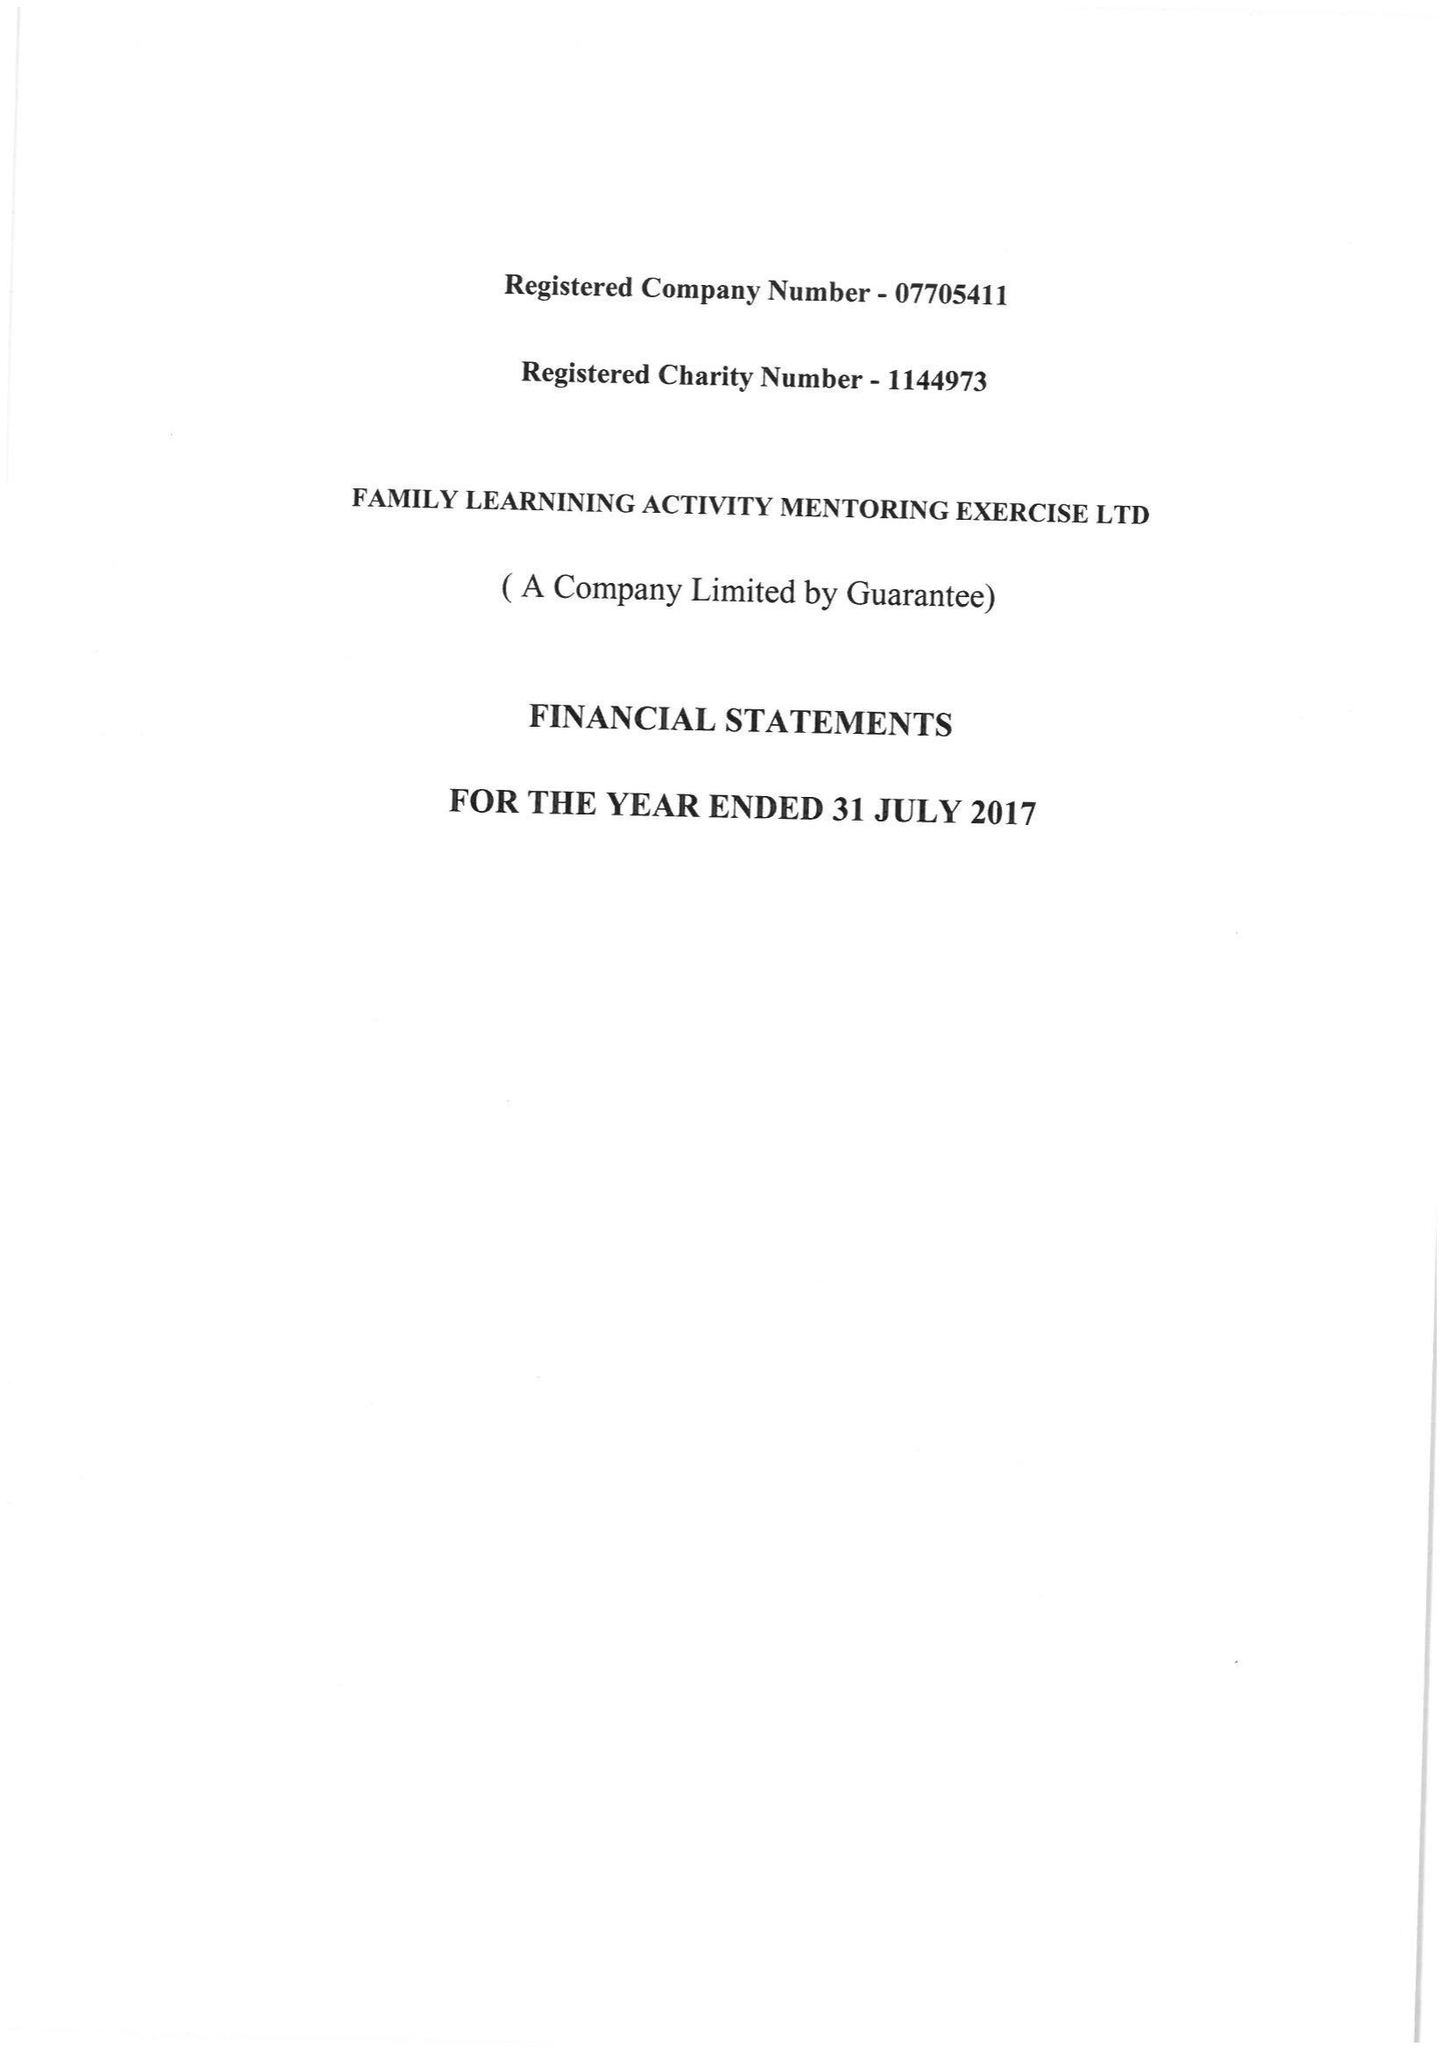What is the value for the charity_number?
Answer the question using a single word or phrase. 1144973 